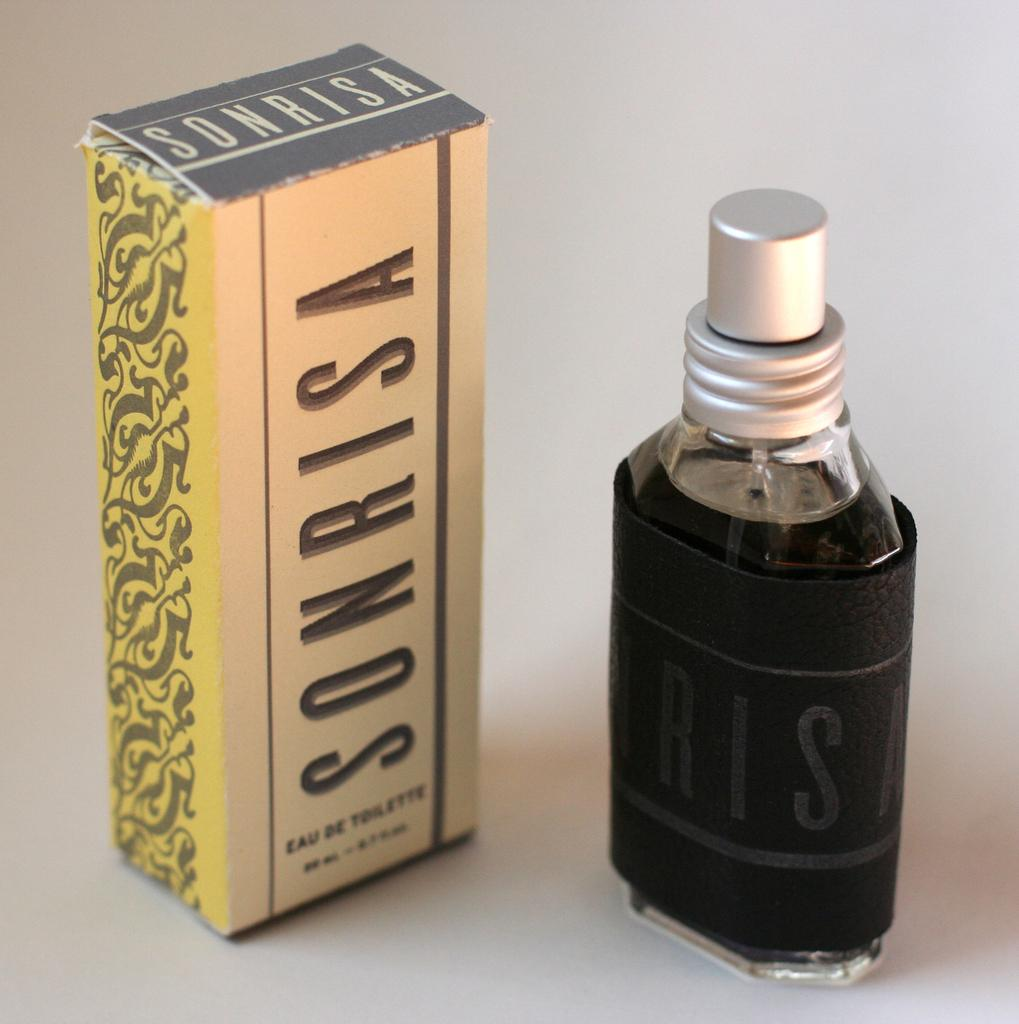<image>
Write a terse but informative summary of the picture. A bottle of perfume with Sonrisa on the box 